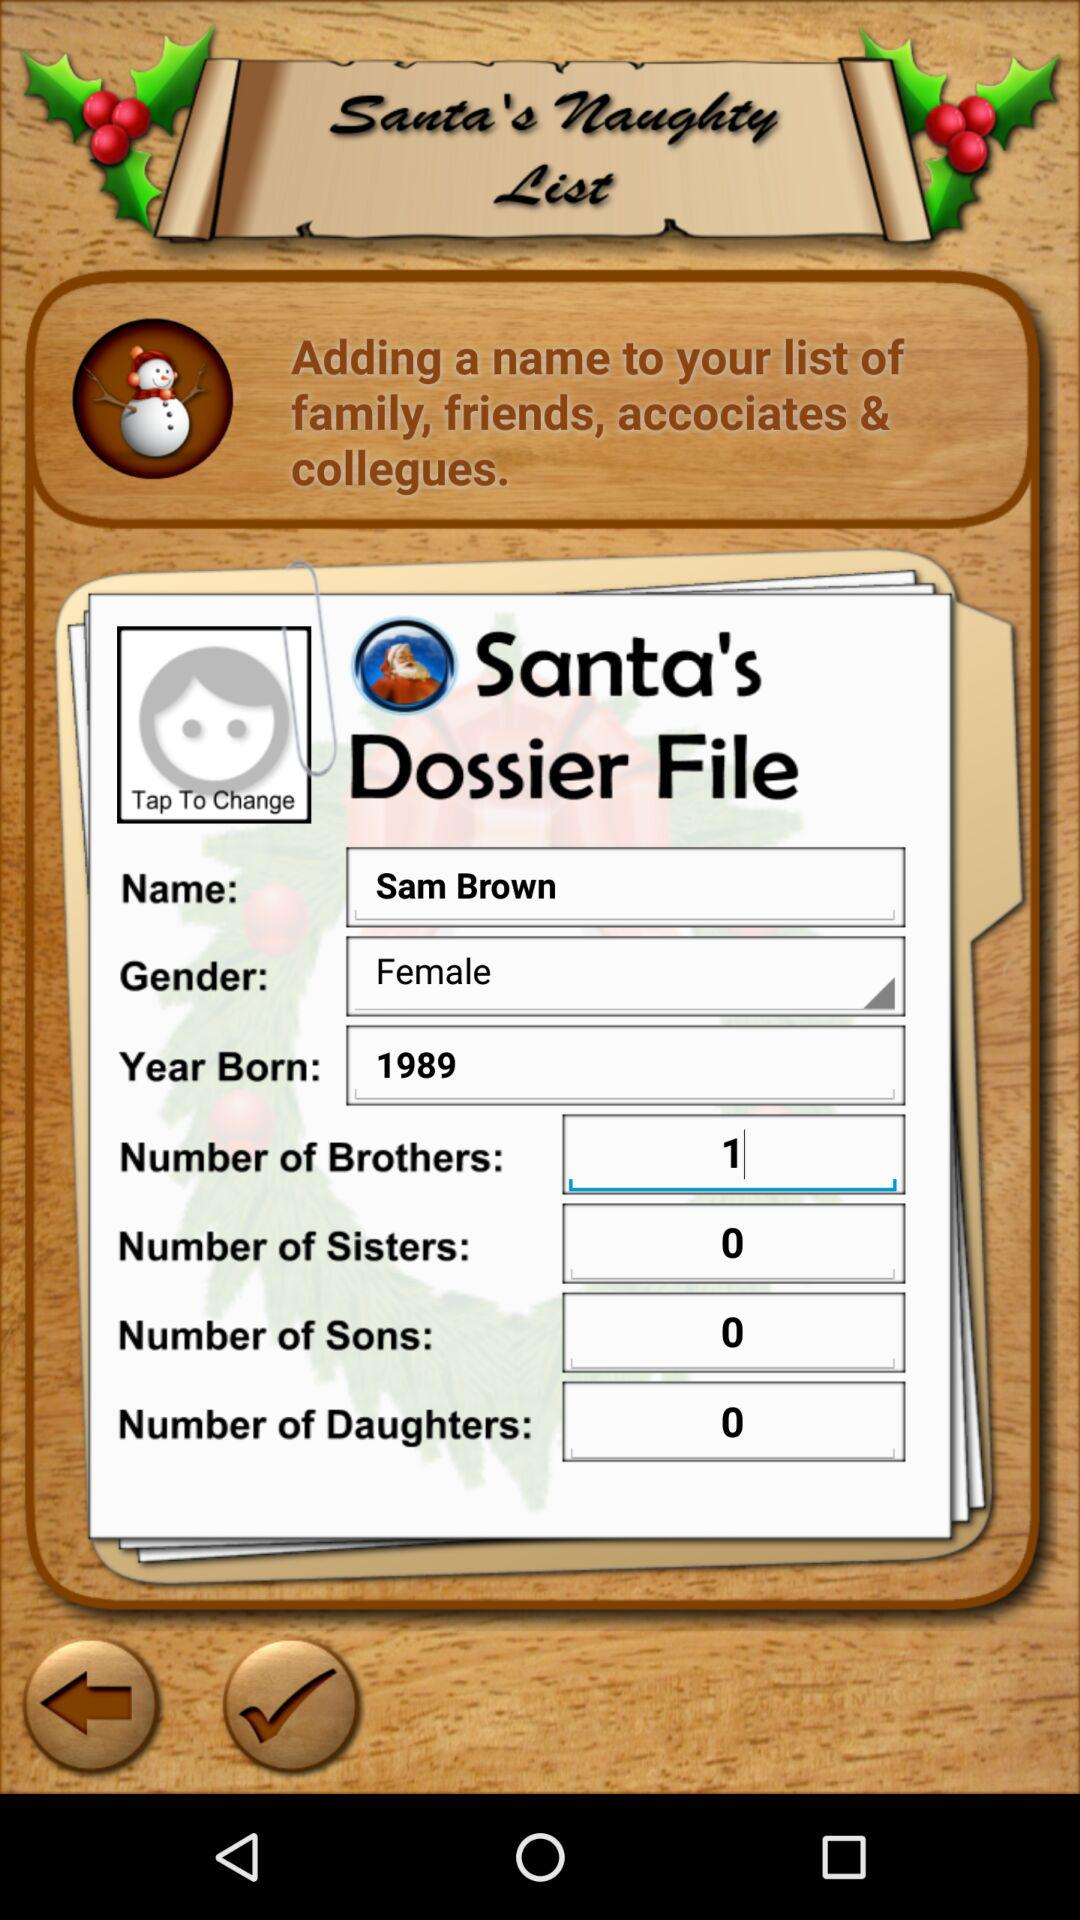Will the user get coal or a gift from Santa for Christmas this year?
When the provided information is insufficient, respond with <no answer>. <no answer> 